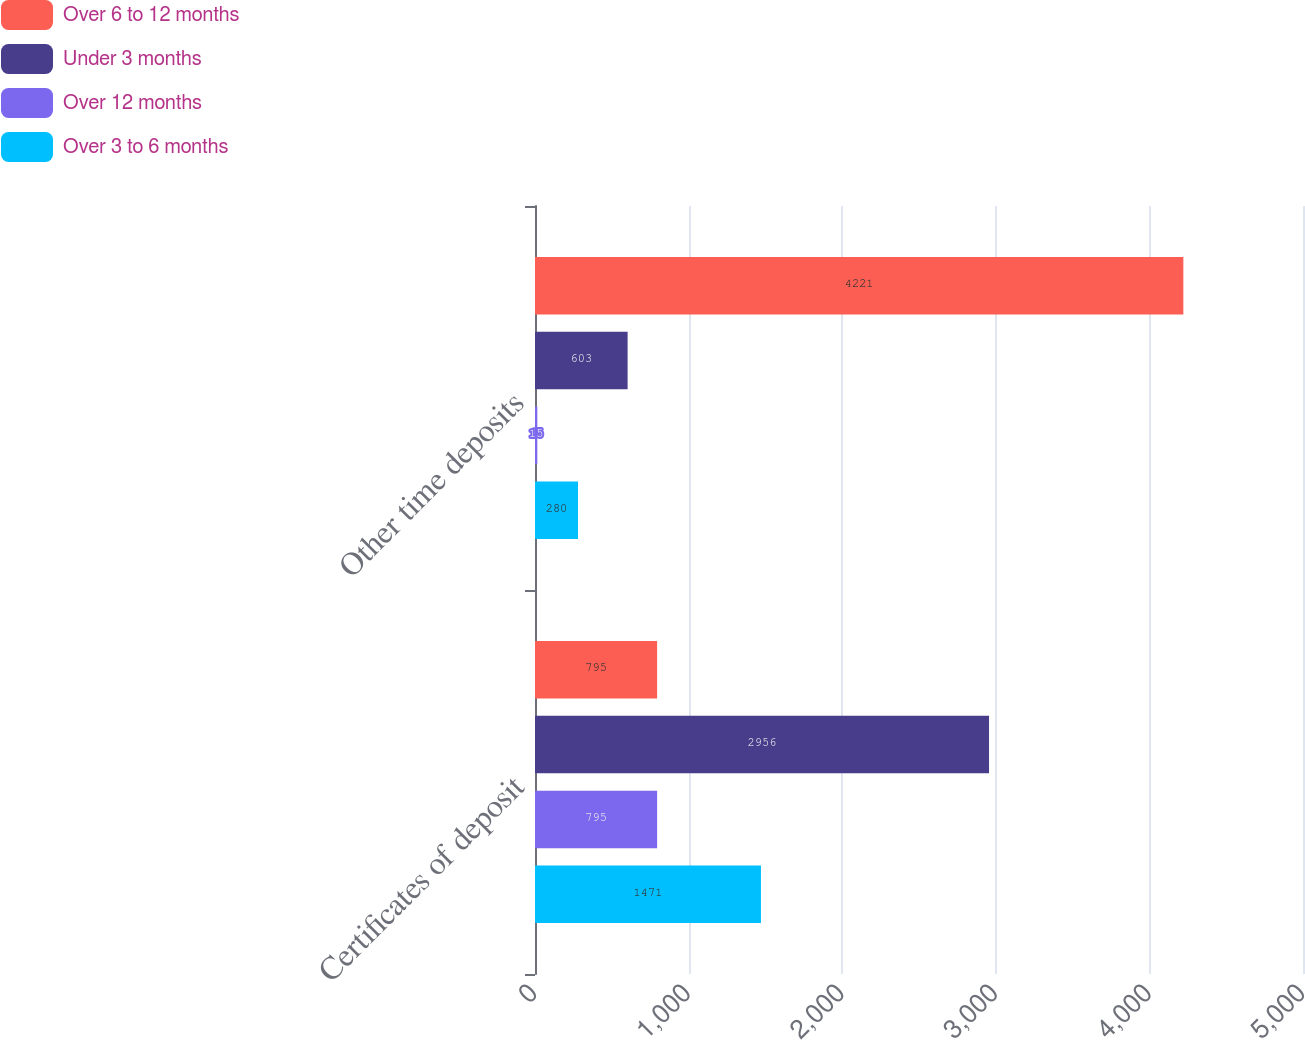Convert chart to OTSL. <chart><loc_0><loc_0><loc_500><loc_500><stacked_bar_chart><ecel><fcel>Certificates of deposit<fcel>Other time deposits<nl><fcel>Over 6 to 12 months<fcel>795<fcel>4221<nl><fcel>Under 3 months<fcel>2956<fcel>603<nl><fcel>Over 12 months<fcel>795<fcel>15<nl><fcel>Over 3 to 6 months<fcel>1471<fcel>280<nl></chart> 